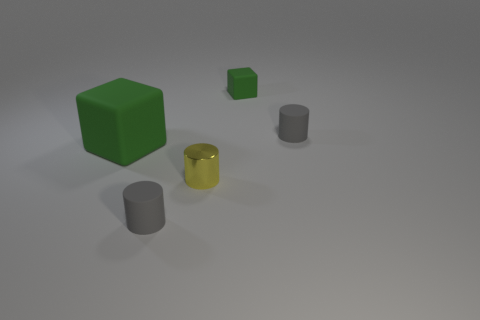Subtract all gray cylinders. How many cylinders are left? 1 Subtract 1 cylinders. How many cylinders are left? 2 Subtract all gray blocks. How many gray cylinders are left? 2 Add 1 gray matte things. How many objects exist? 6 Subtract all cylinders. How many objects are left? 2 Add 1 yellow things. How many yellow things are left? 2 Add 5 metal cylinders. How many metal cylinders exist? 6 Subtract 0 yellow spheres. How many objects are left? 5 Subtract all purple cylinders. Subtract all gray blocks. How many cylinders are left? 3 Subtract all tiny gray rubber cylinders. Subtract all yellow cylinders. How many objects are left? 2 